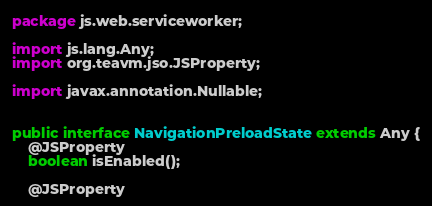Convert code to text. <code><loc_0><loc_0><loc_500><loc_500><_Java_>package js.web.serviceworker;

import js.lang.Any;
import org.teavm.jso.JSProperty;

import javax.annotation.Nullable;


public interface NavigationPreloadState extends Any {
    @JSProperty
    boolean isEnabled();

    @JSProperty</code> 